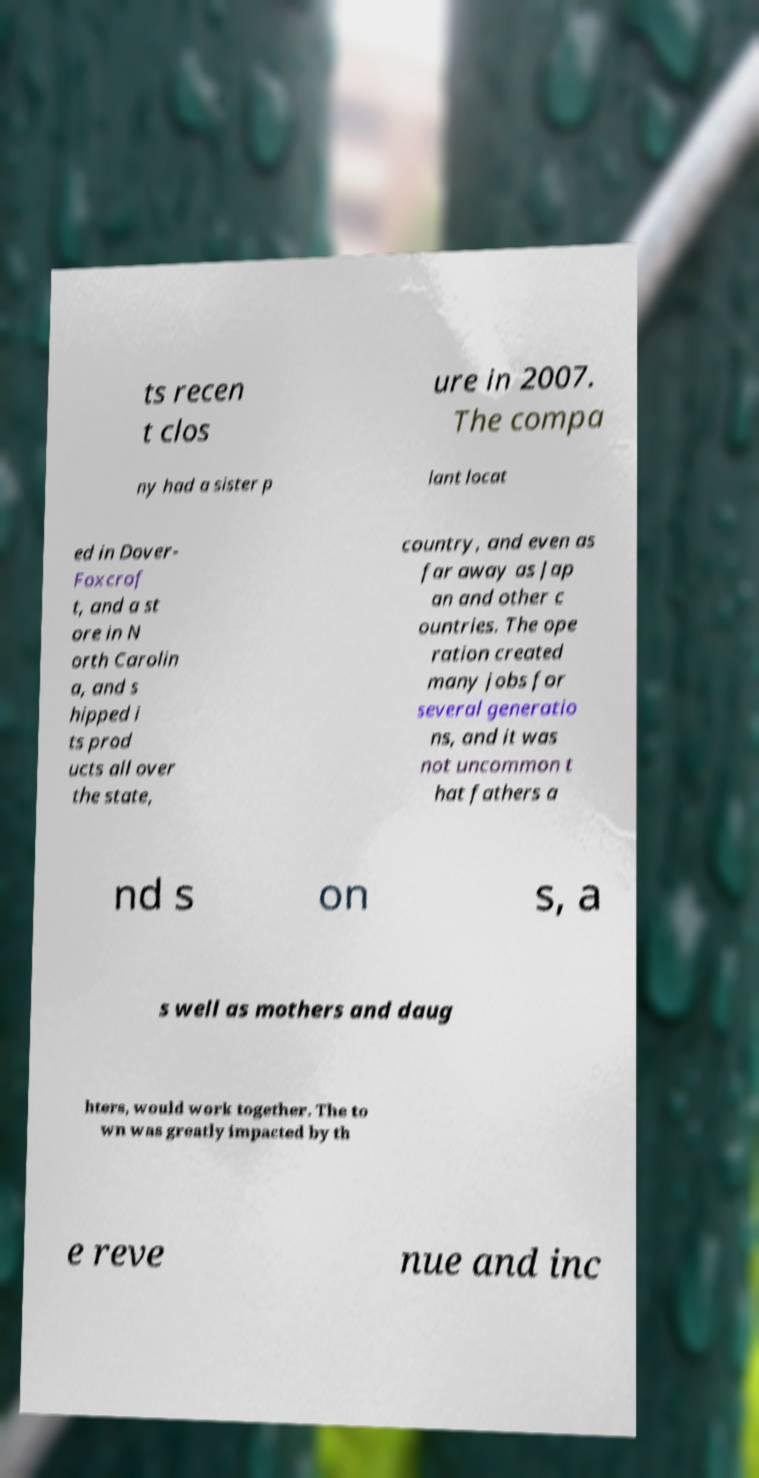Can you read and provide the text displayed in the image?This photo seems to have some interesting text. Can you extract and type it out for me? ts recen t clos ure in 2007. The compa ny had a sister p lant locat ed in Dover- Foxcrof t, and a st ore in N orth Carolin a, and s hipped i ts prod ucts all over the state, country, and even as far away as Jap an and other c ountries. The ope ration created many jobs for several generatio ns, and it was not uncommon t hat fathers a nd s on s, a s well as mothers and daug hters, would work together. The to wn was greatly impacted by th e reve nue and inc 